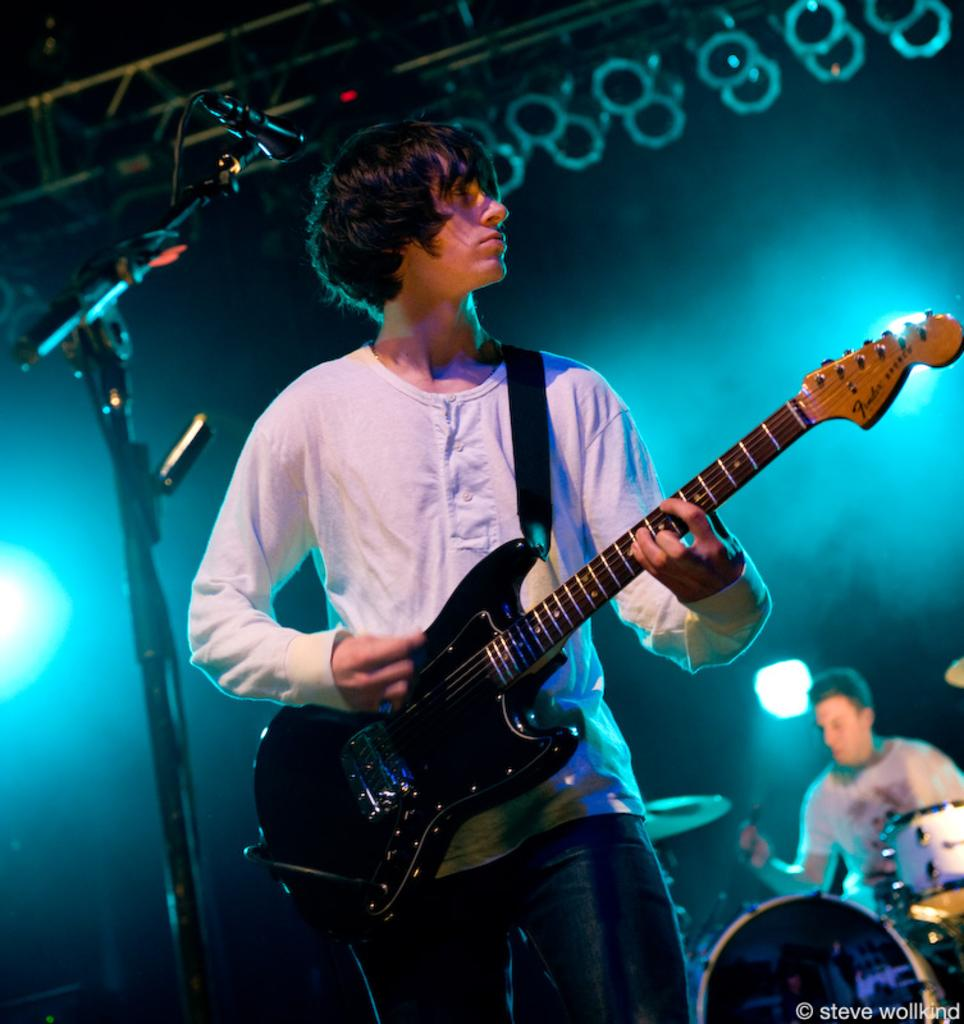What is the man in the image doing? The man is playing the guitar in the image. What instrument is the man holding? The man is holding a guitar. Is there any equipment near the man? Yes, there is a microphone in front of the man. What other musician can be seen in the image? There is a person playing drums in the background. What can be seen in the image that might indicate a performance setting? There is lighting visible in the image. Can you see any railway tracks or camping equipment in the image? No, there are no railway tracks or camping equipment present in the image. Is the man playing the guitar in the wilderness? The provided facts do not indicate whether the image is set in the wilderness or not. 